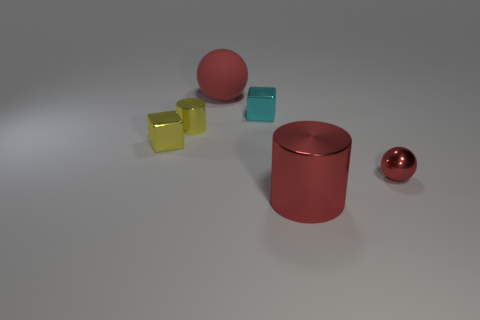Is the color of the large rubber thing the same as the big cylinder?
Your answer should be very brief. Yes. There is a sphere that is the same color as the large matte object; what is its size?
Your response must be concise. Small. Is there a large gray cube that has the same material as the large red cylinder?
Your answer should be compact. No. Is the material of the small block left of the red rubber object the same as the red thing behind the small red sphere?
Make the answer very short. No. How many rubber objects are there?
Provide a short and direct response. 1. The large red object that is in front of the small red thing has what shape?
Give a very brief answer. Cylinder. How many other things are there of the same size as the cyan thing?
Offer a very short reply. 3. Does the big object that is in front of the small shiny cylinder have the same shape as the yellow metal object to the right of the yellow shiny block?
Keep it short and to the point. Yes. How many small cubes are left of the cyan metallic cube?
Your answer should be very brief. 1. There is a object on the left side of the tiny metallic cylinder; what color is it?
Provide a short and direct response. Yellow. 